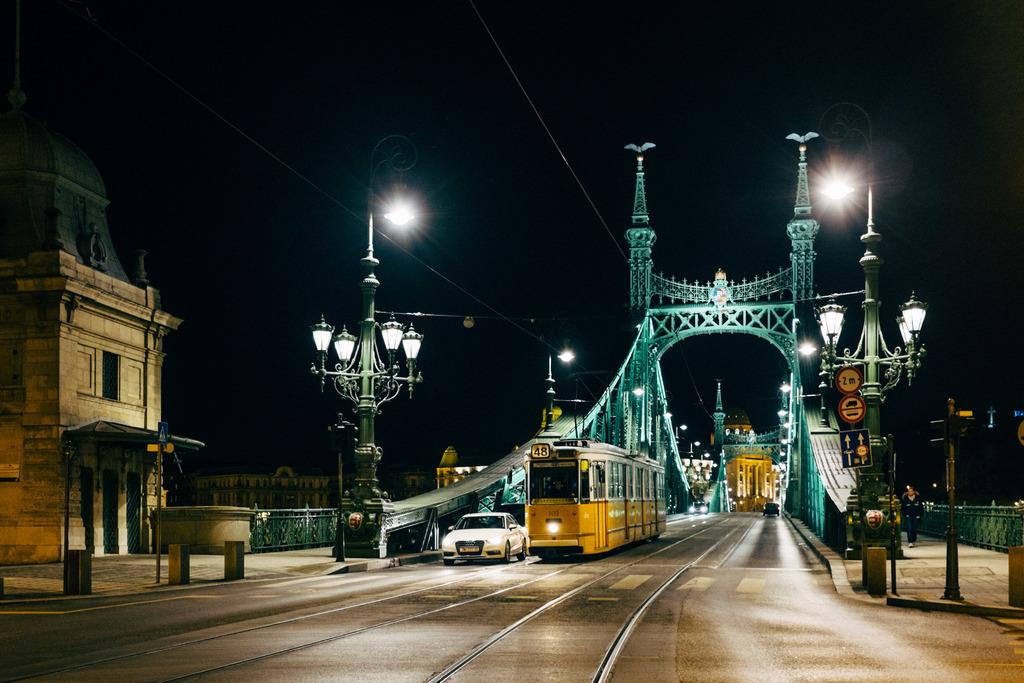What type of infrastructure is present in the image? There is a bridge in the image. What mode of transportation can be seen in the image? A train and a car are present in the image. Are there any other vehicles visible in the image? Yes, there are vehicles in the image. What are the poles and cables used for in the image? The poles and cables are likely used for supporting and transmitting power or communication signals. Can you describe the people in the image? People are present in the image, but their specific actions or activities are not clear. What is the surface on which the car and vehicles are traveling? There is a road in the image. What is visible in the background of the image? The sky is visible in the image. How many fingers can be seen on the back of the minute hand in the image? There is no clock or minute hand present in the image. What type of back support is provided for the people in the image? There is no specific back support mentioned or visible in the image. 